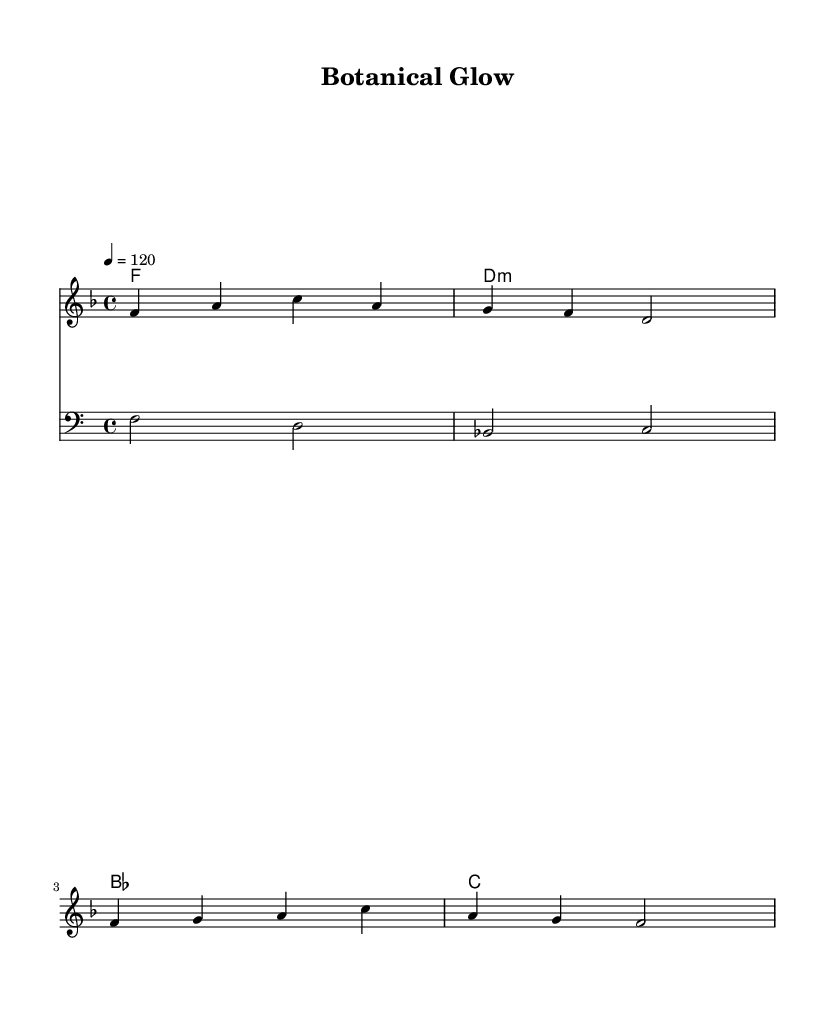What is the key signature of this music? The key signature is F major, which has one flat (B flat). This can be identified from the key notation at the beginning of the score.
Answer: F major What is the time signature of this piece? The time signature is 4/4, indicated at the beginning of the music. This means there are four beats in each measure and the quarter note receives one beat.
Answer: 4/4 What is the tempo marking for this piece? The tempo marking is 120 beats per minute, specified at the beginning with the instruction "4 = 120". This indicates the speed of the music.
Answer: 120 What is the structure of the harmony chords in this score? The harmony consists of four chords: F, D minor, B flat, and C. These chords are listed vertically in the ChordNames section.
Answer: F, D minor, B flat, C How many measures are there in the melody? The melody consists of four measures, which can be counted in the melody staff where the music is divided into groups of four beats each.
Answer: 4 What musical style does this piece represent? This piece can be categorized as K-Pop synth-pop, as indicated by its use of synthesizers and exploration of themes related to nature and skin health.
Answer: K-Pop synth-pop 